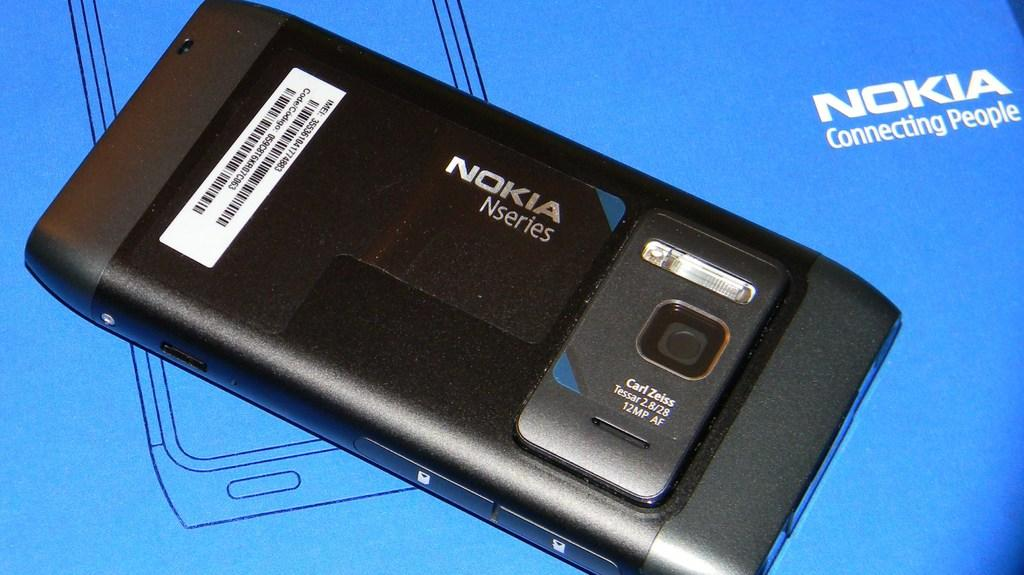<image>
Present a compact description of the photo's key features. A Nokia phone is screen side down on a blue surface. 